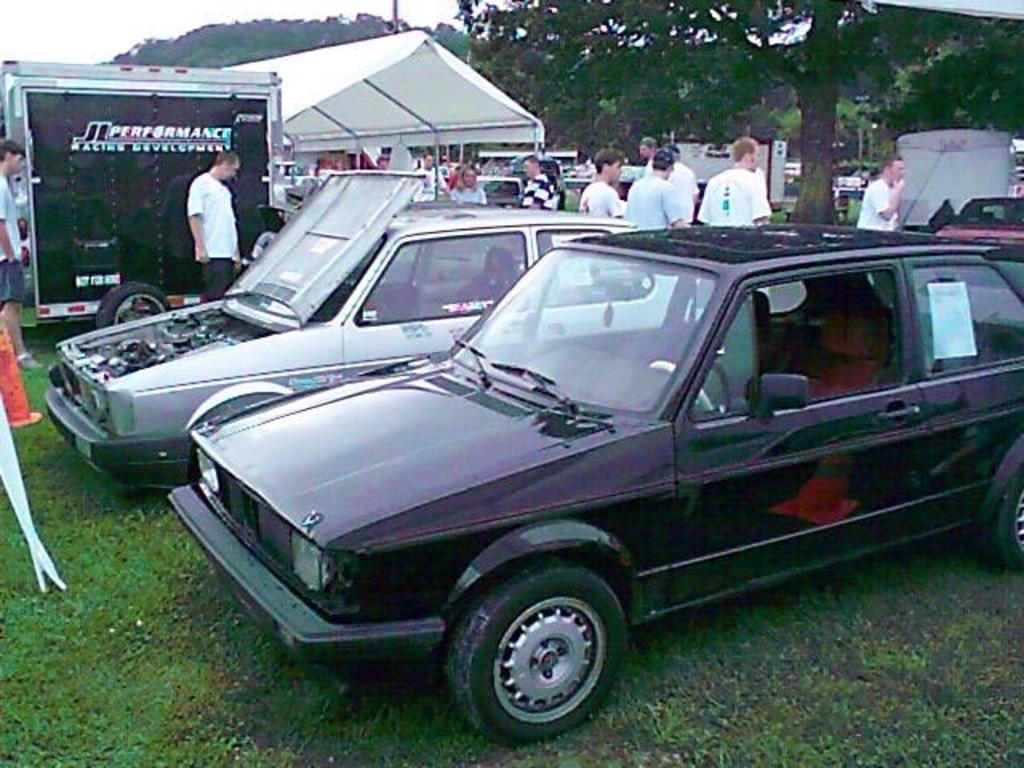Please provide a concise description of this image. In this image, we can see cars. At the bottom, we can see grass. Background we can see few people, vehicles, trees, shed, hill and few objects. On the left of the image, we can see cone. 